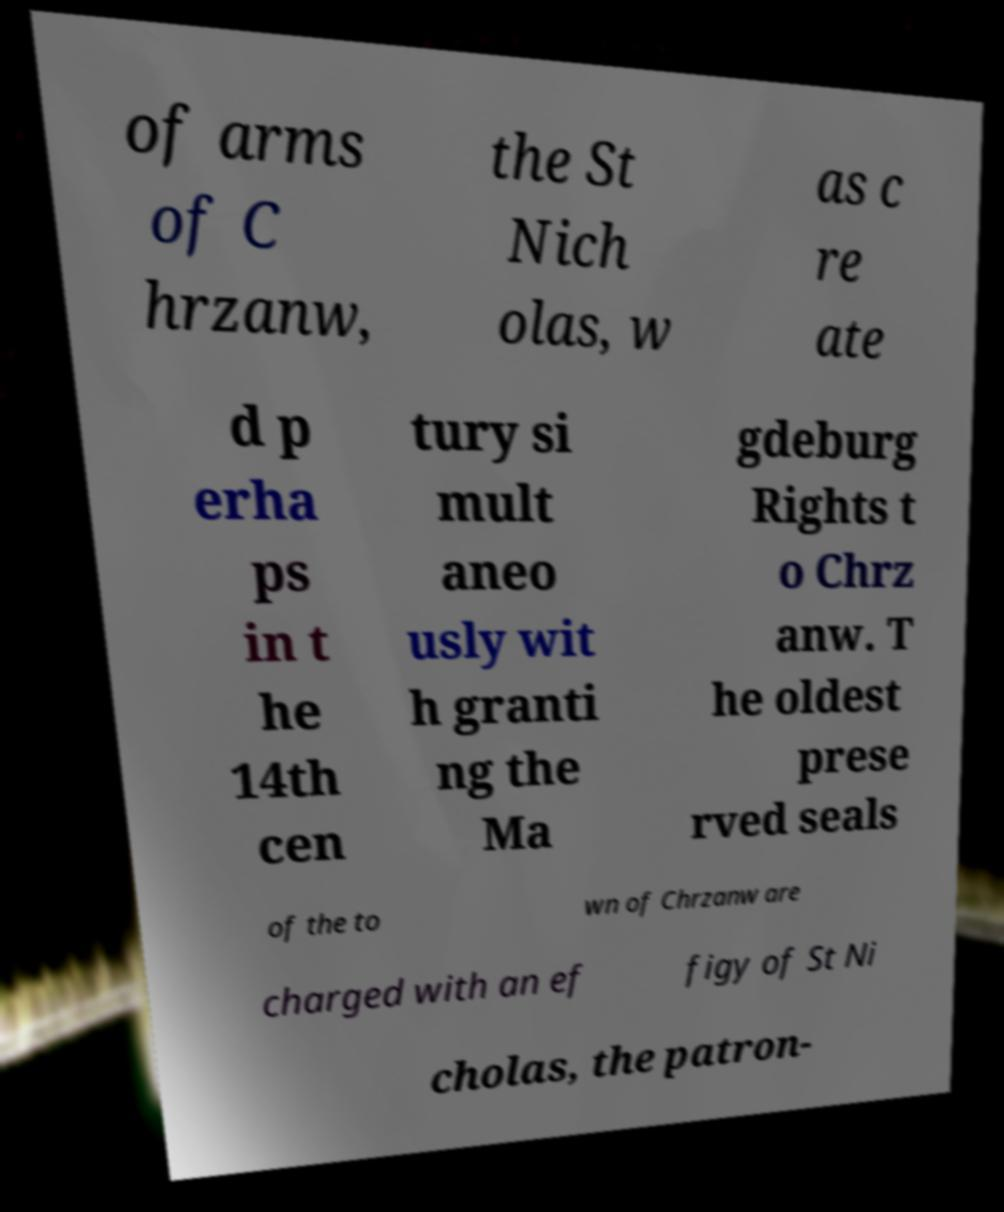Can you accurately transcribe the text from the provided image for me? of arms of C hrzanw, the St Nich olas, w as c re ate d p erha ps in t he 14th cen tury si mult aneo usly wit h granti ng the Ma gdeburg Rights t o Chrz anw. T he oldest prese rved seals of the to wn of Chrzanw are charged with an ef figy of St Ni cholas, the patron- 